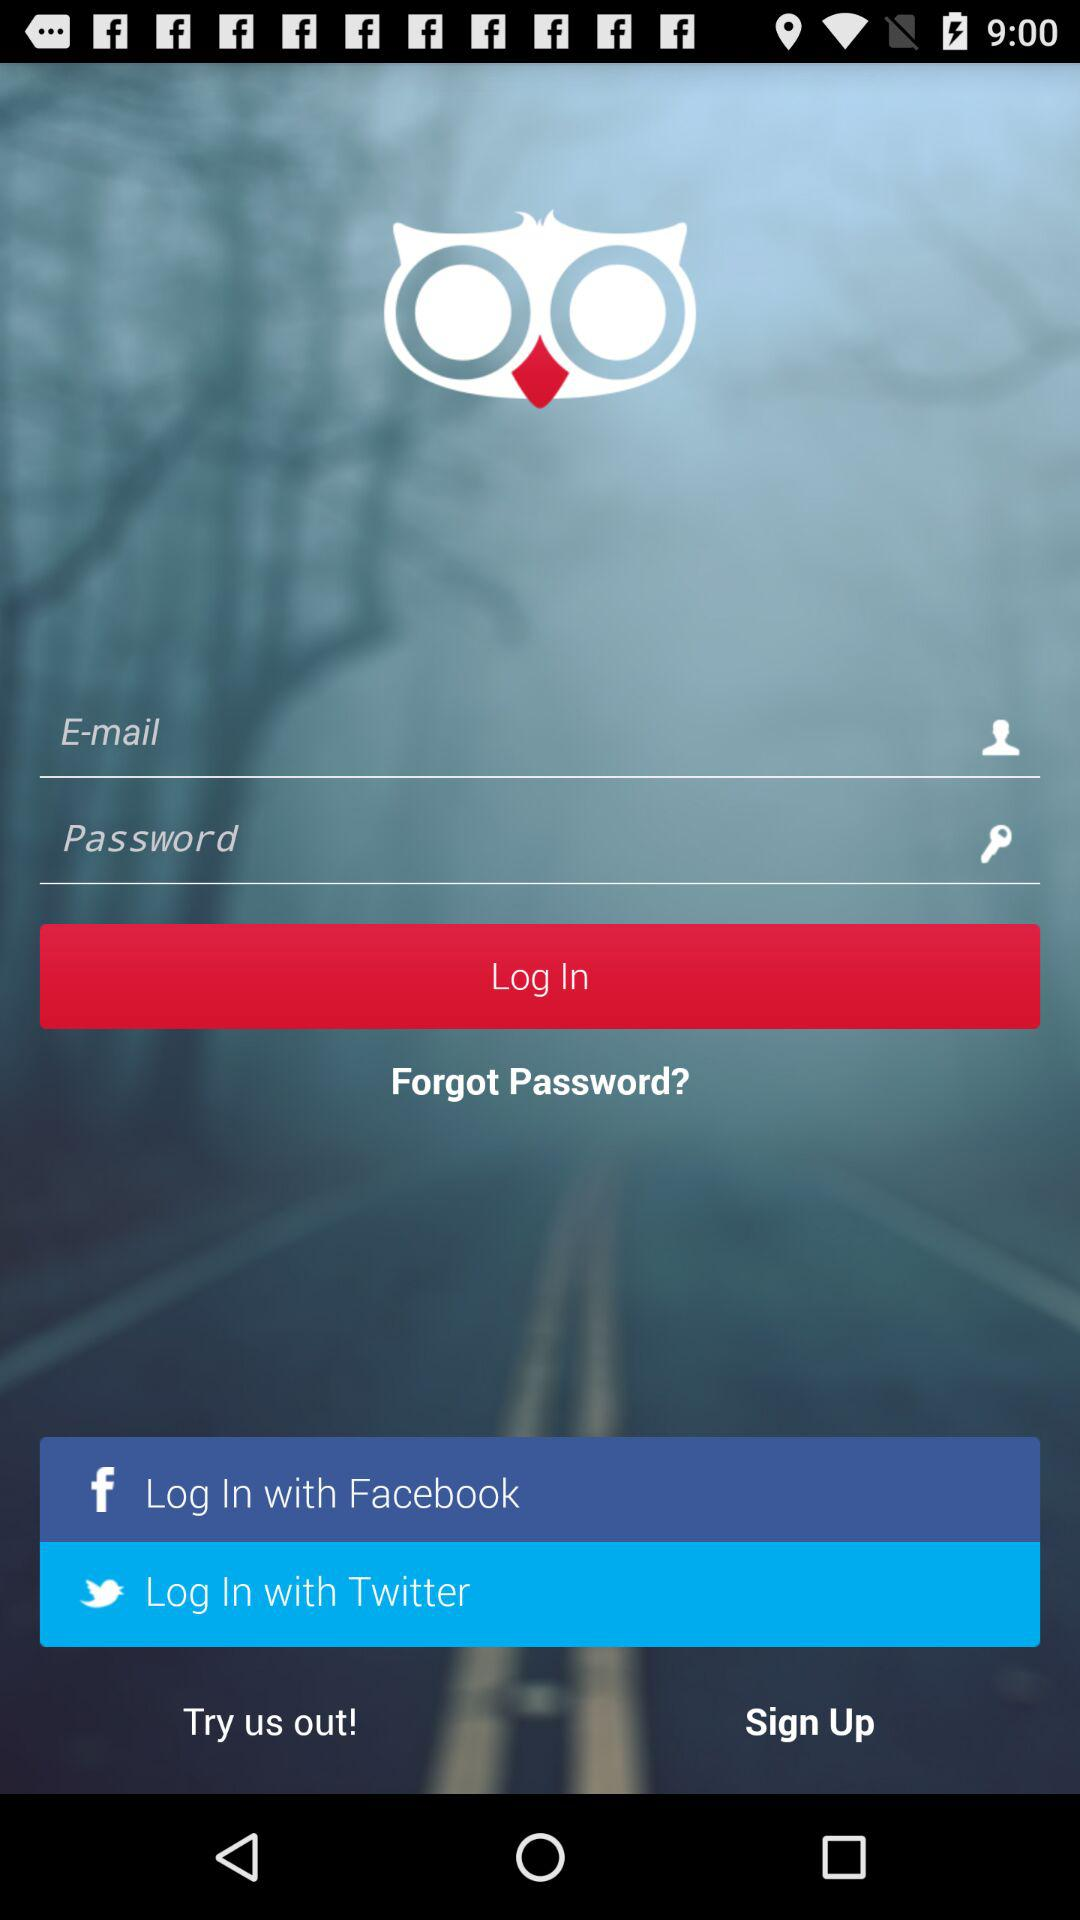How many input fields are there for logging in?
Answer the question using a single word or phrase. 2 